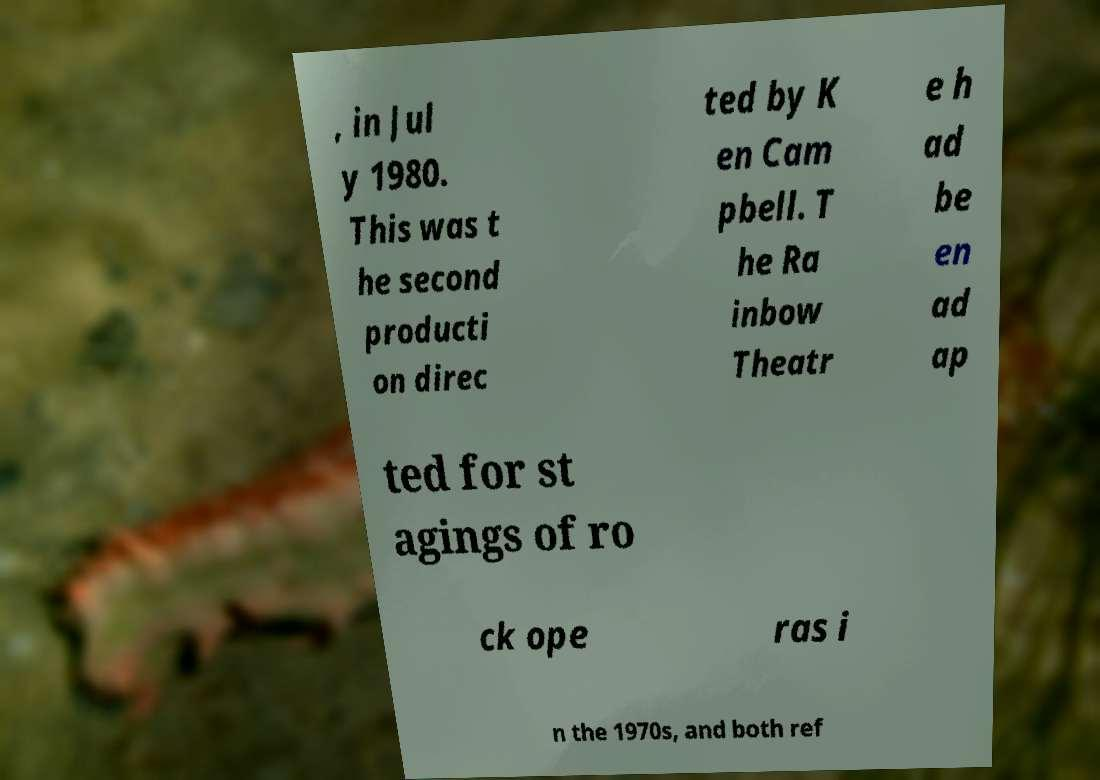Can you read and provide the text displayed in the image?This photo seems to have some interesting text. Can you extract and type it out for me? , in Jul y 1980. This was t he second producti on direc ted by K en Cam pbell. T he Ra inbow Theatr e h ad be en ad ap ted for st agings of ro ck ope ras i n the 1970s, and both ref 